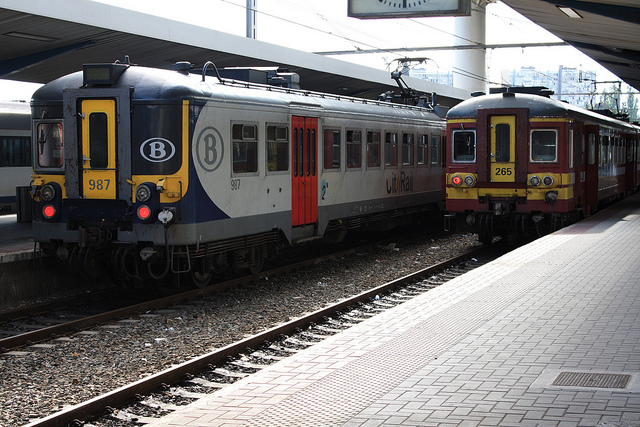How many trains are there? There are two trains visible in the image, each on separate tracks and appearing to be stationary at the platform. 